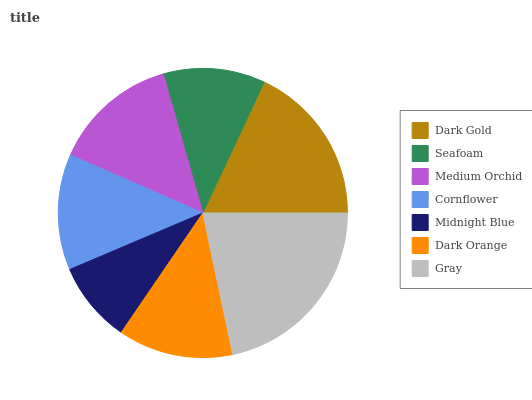Is Midnight Blue the minimum?
Answer yes or no. Yes. Is Gray the maximum?
Answer yes or no. Yes. Is Seafoam the minimum?
Answer yes or no. No. Is Seafoam the maximum?
Answer yes or no. No. Is Dark Gold greater than Seafoam?
Answer yes or no. Yes. Is Seafoam less than Dark Gold?
Answer yes or no. Yes. Is Seafoam greater than Dark Gold?
Answer yes or no. No. Is Dark Gold less than Seafoam?
Answer yes or no. No. Is Cornflower the high median?
Answer yes or no. Yes. Is Cornflower the low median?
Answer yes or no. Yes. Is Dark Gold the high median?
Answer yes or no. No. Is Medium Orchid the low median?
Answer yes or no. No. 